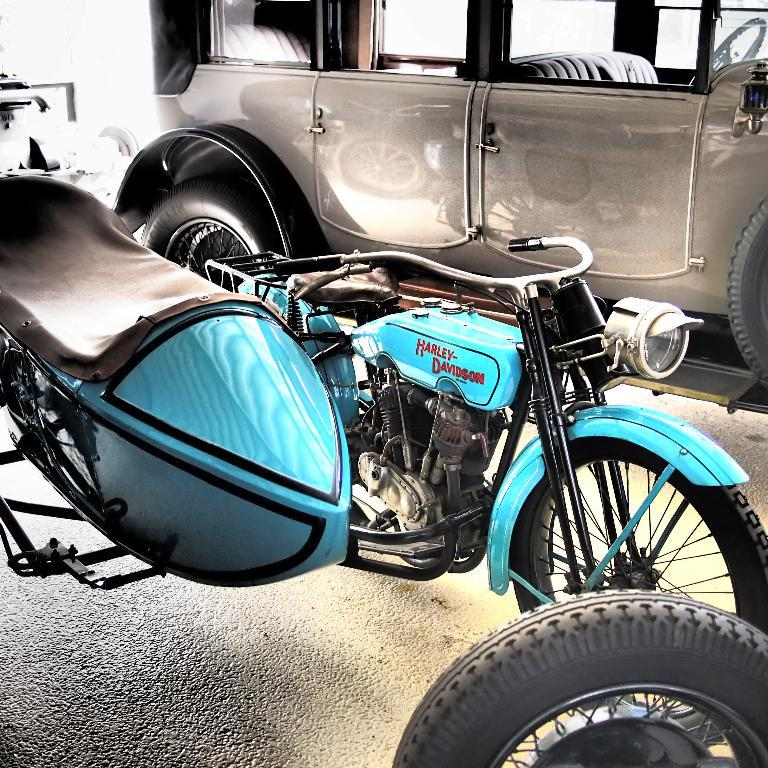What type of vehicle is blue in the image? There is a blue bike in the image. What other vehicle can be seen in the image? There is a grey car at the top of the image. What type of seat is visible in the image? There is no seat present in the image. What arithmetic problem can be solved using the license plate numbers of the vehicles in the image? There is no information about license plate numbers in the image, so it is not possible to solve an arithmetic problem based on the image. 